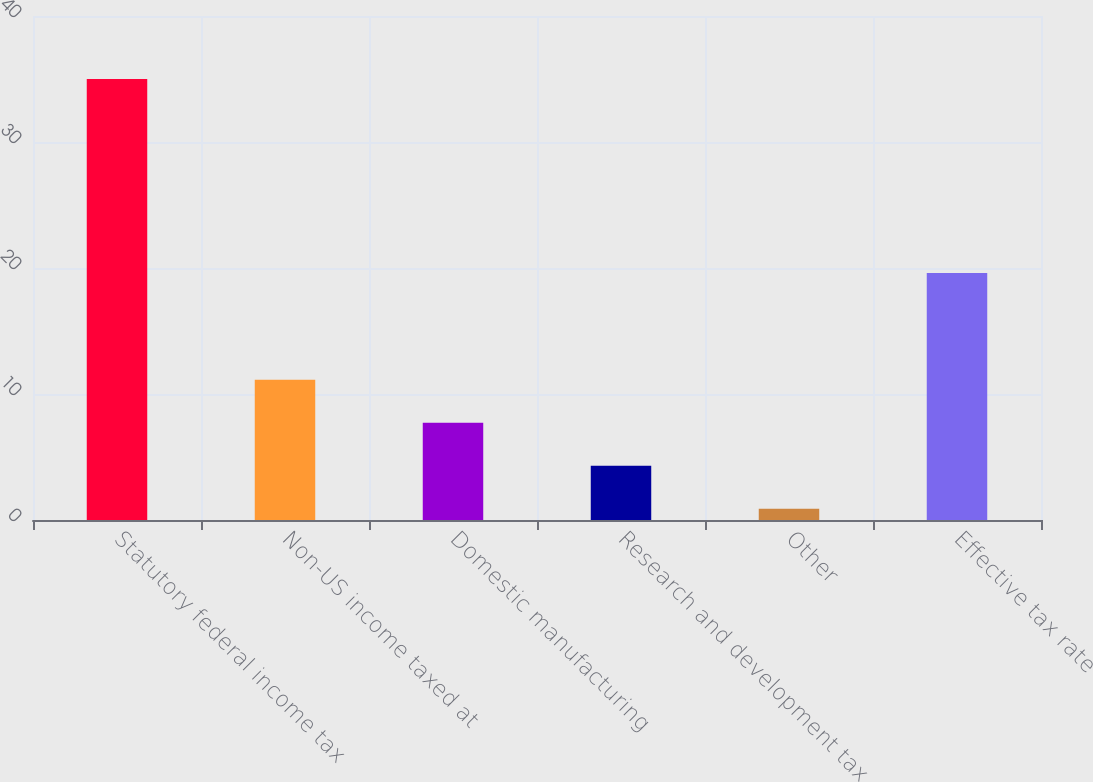Convert chart. <chart><loc_0><loc_0><loc_500><loc_500><bar_chart><fcel>Statutory federal income tax<fcel>Non-US income taxed at<fcel>Domestic manufacturing<fcel>Research and development tax<fcel>Other<fcel>Effective tax rate<nl><fcel>35<fcel>11.13<fcel>7.72<fcel>4.31<fcel>0.9<fcel>19.6<nl></chart> 